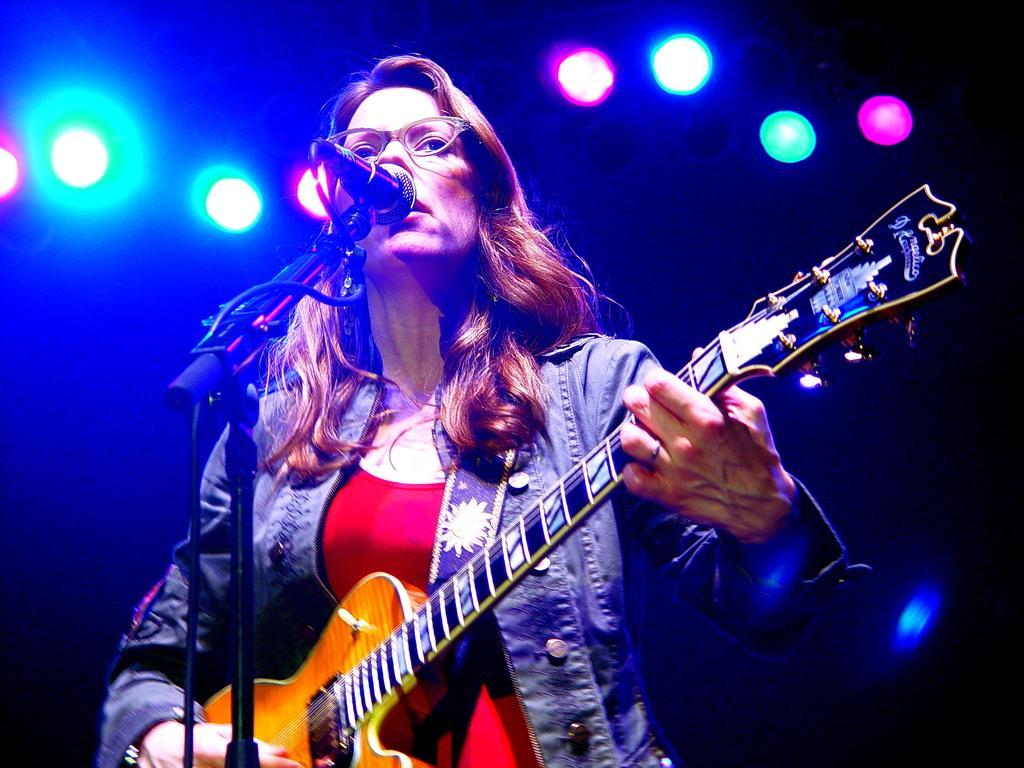Please provide a concise description of this image. In this image, There is a woman standing and she is holding some music instrument and there is a microphone which is in black color and she is singing in microphone and in the background there is colorful lights in the background. 